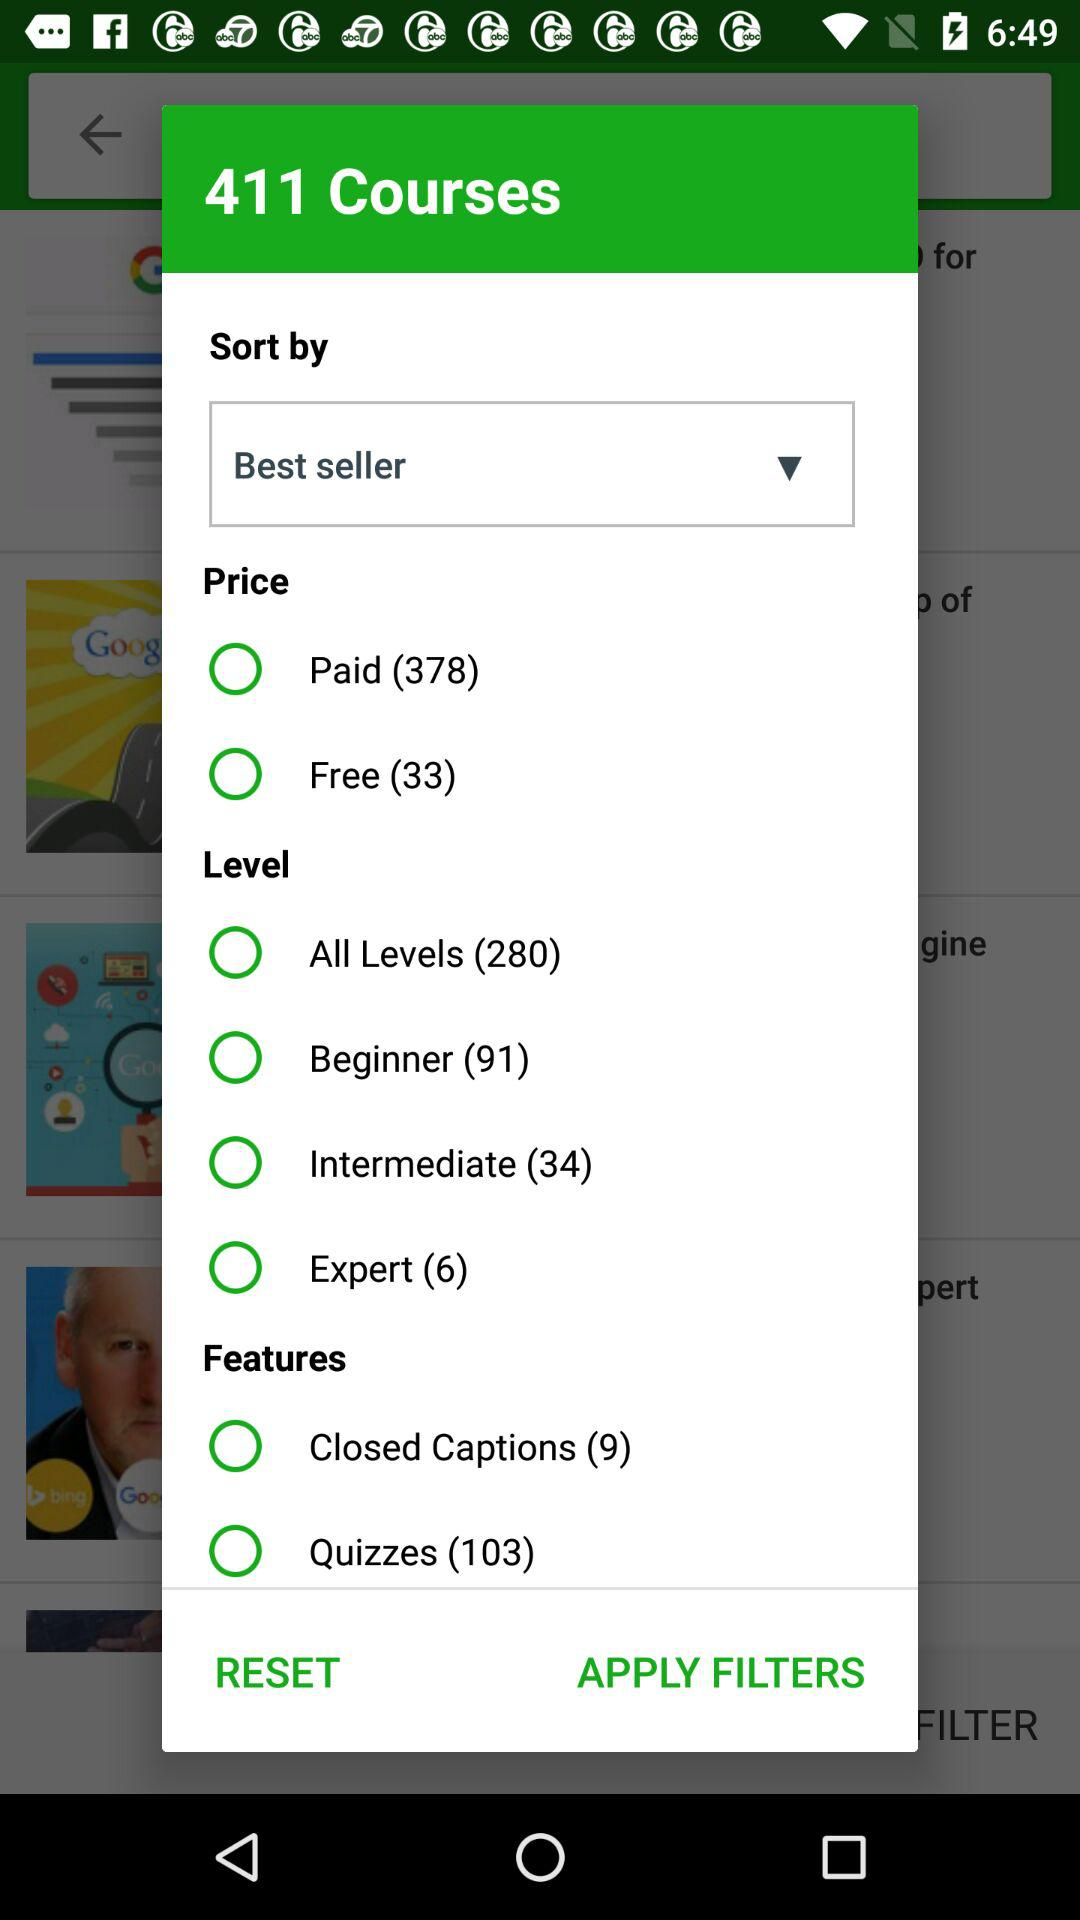What is the selected sort order for the courses? The selected order is "Best seller". 